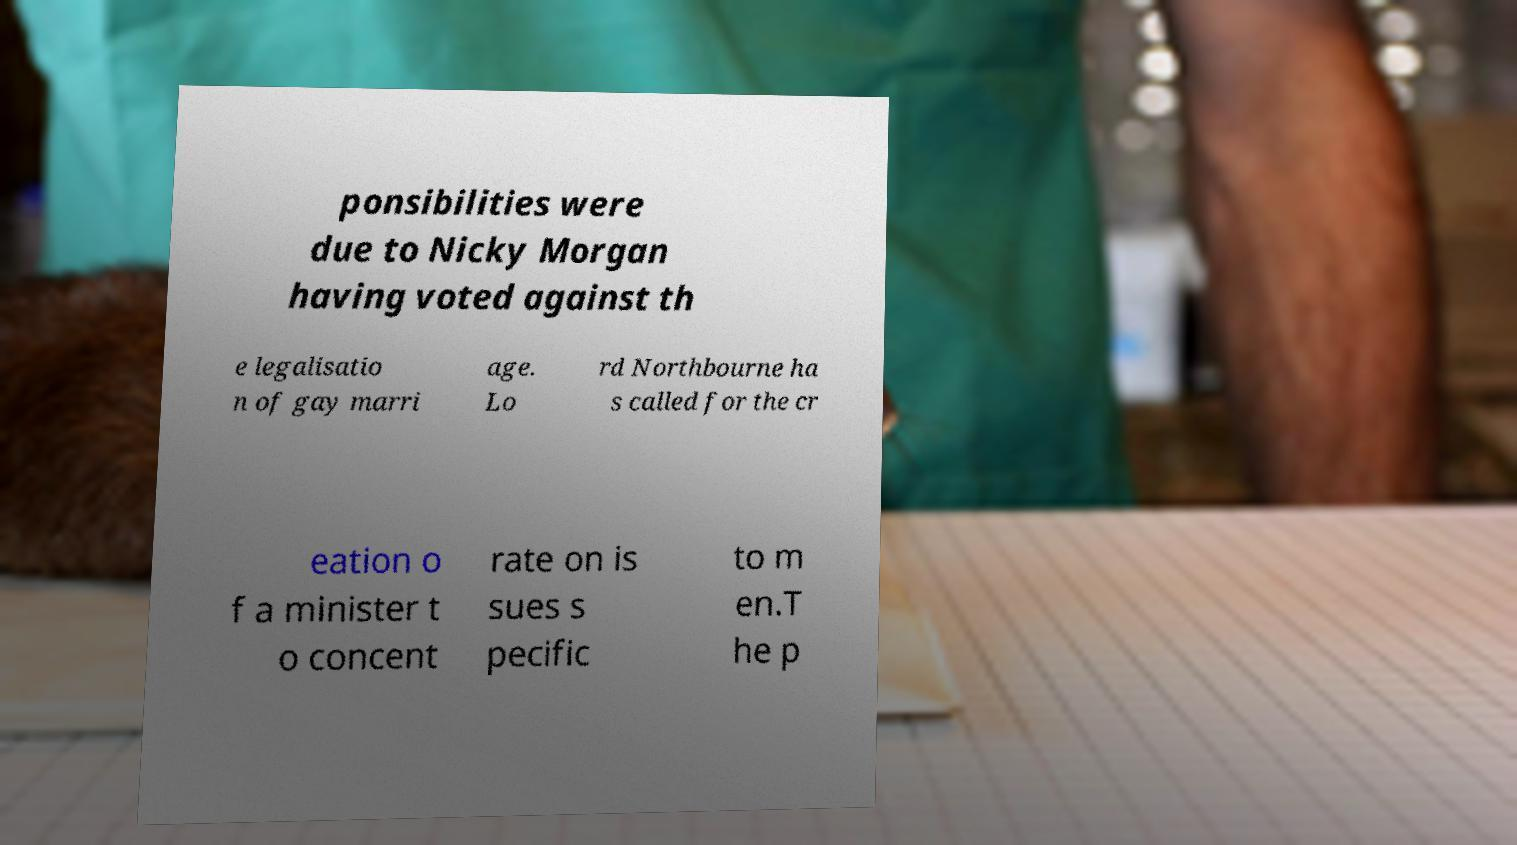Could you assist in decoding the text presented in this image and type it out clearly? ponsibilities were due to Nicky Morgan having voted against th e legalisatio n of gay marri age. Lo rd Northbourne ha s called for the cr eation o f a minister t o concent rate on is sues s pecific to m en.T he p 